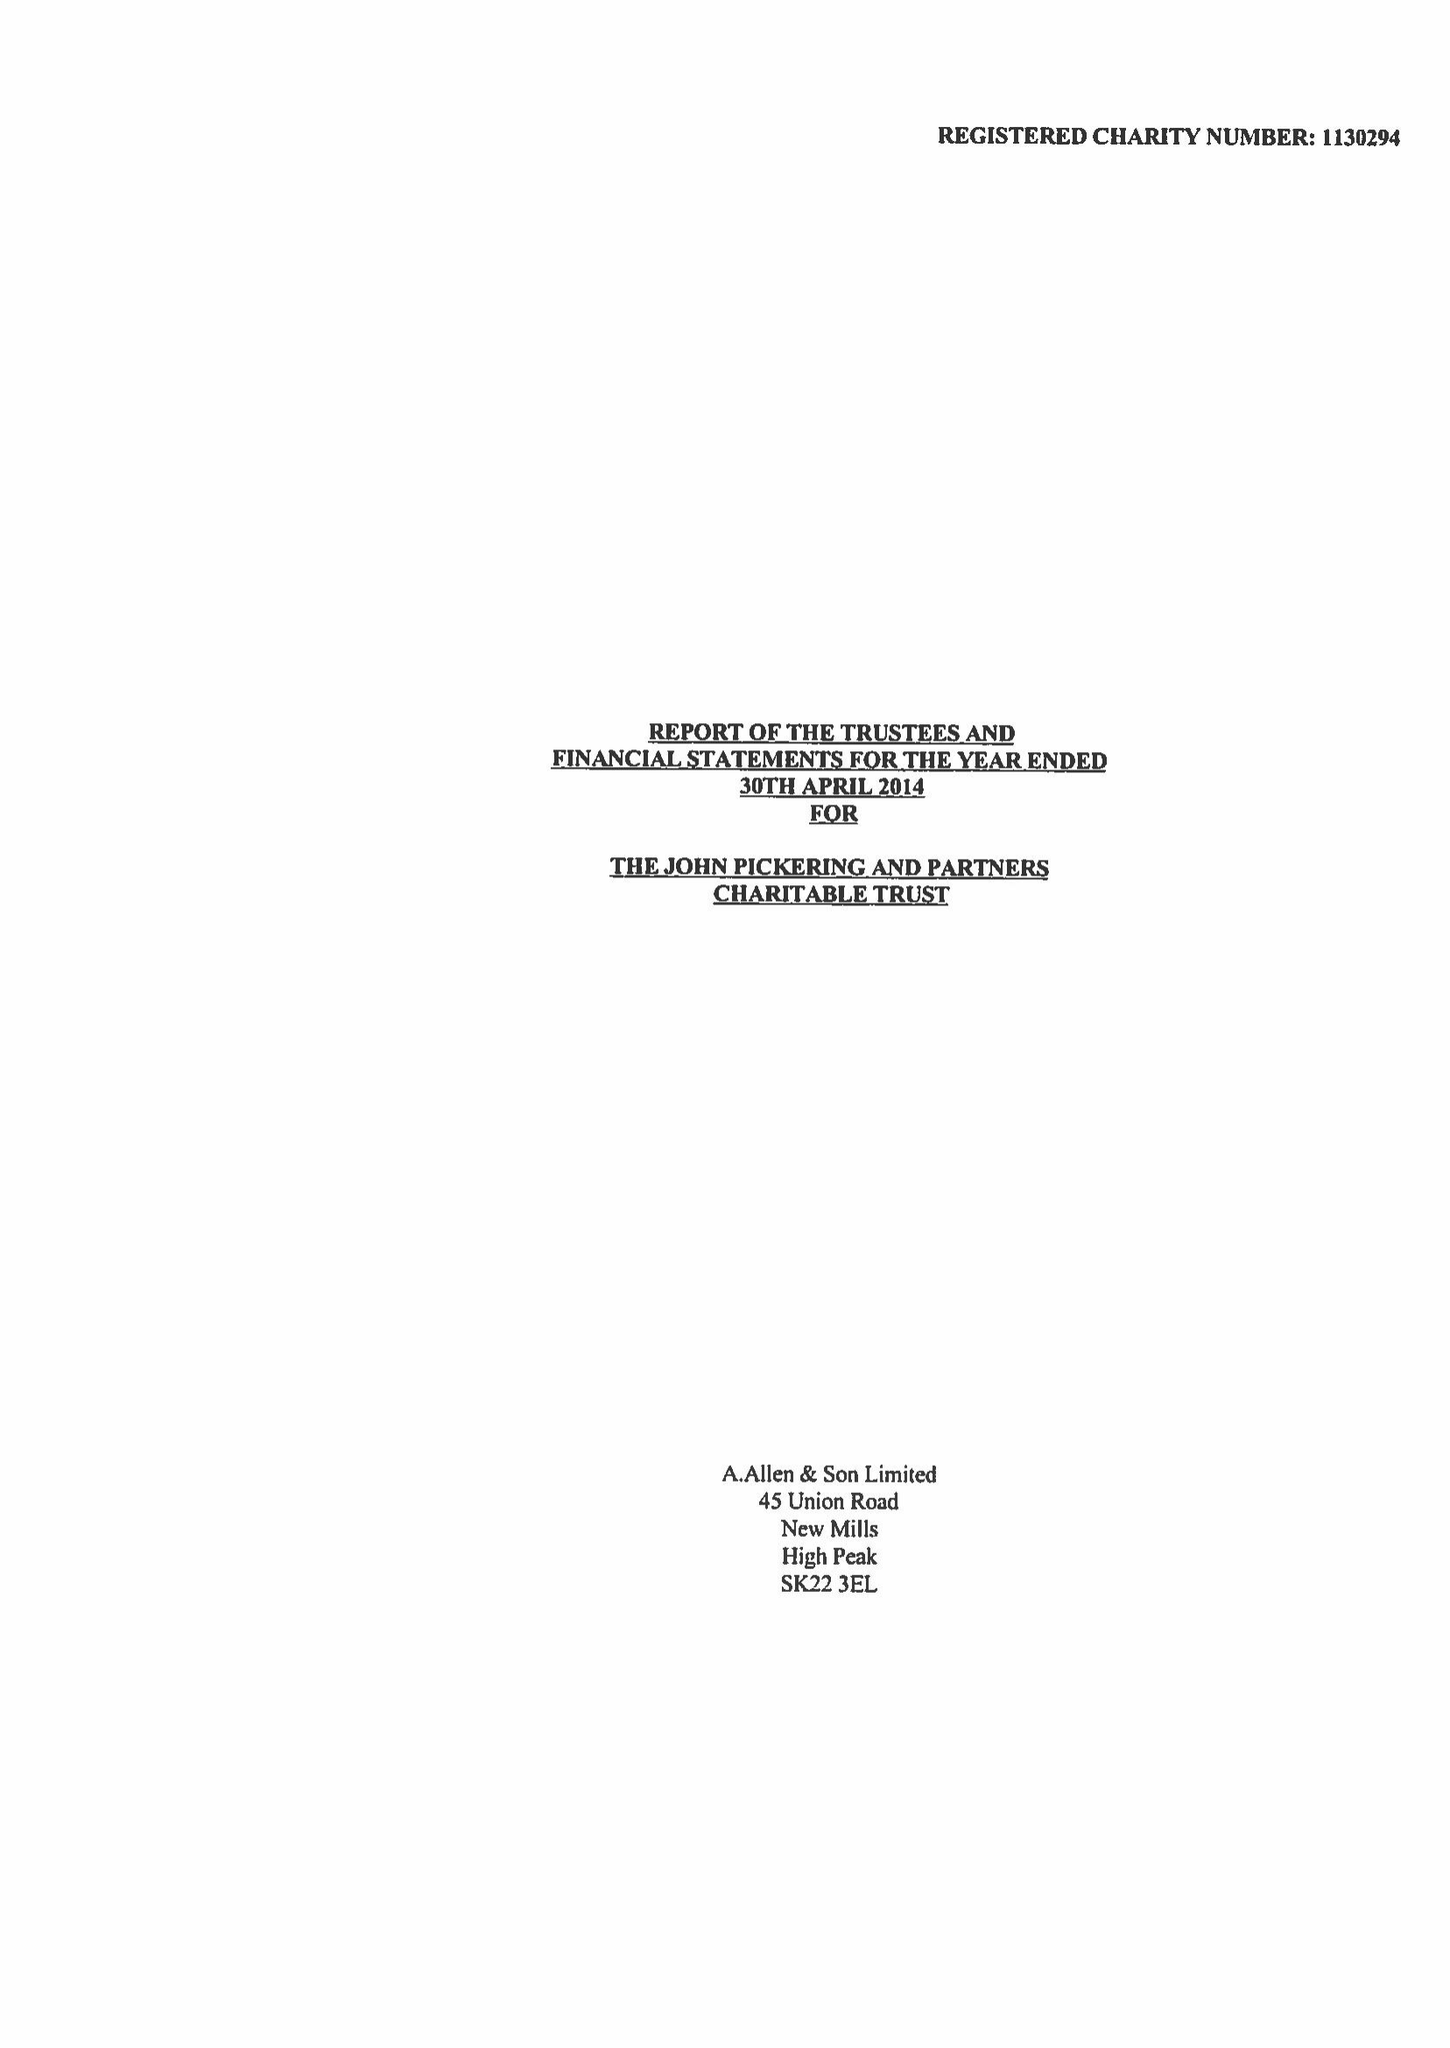What is the value for the income_annually_in_british_pounds?
Answer the question using a single word or phrase. 72020.00 